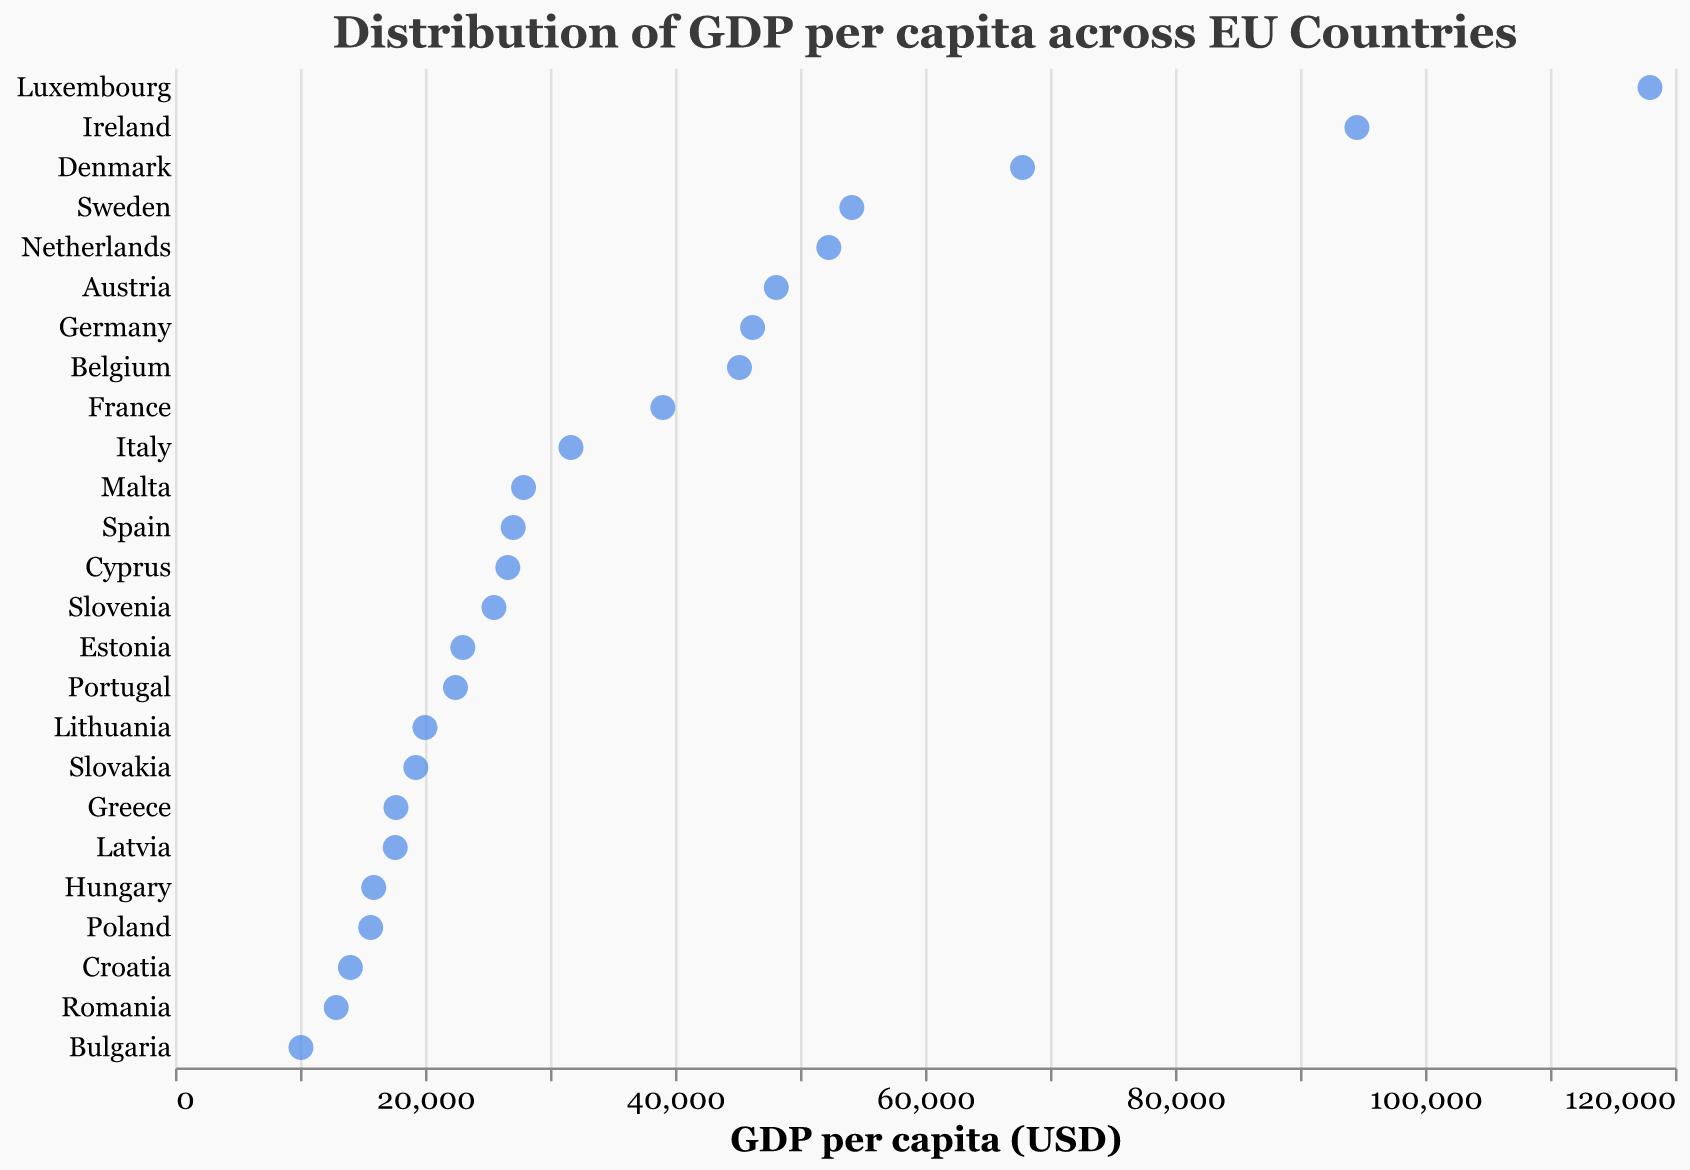Which country has the highest GDP per capita? The plot shows GDP per capita on the x-axis and countries on the y-axis. The point farthest to the right represents the highest GDP per capita. Luxembourg is the country farthest to the right.
Answer: Luxembourg Which country has the lowest GDP per capita? To find the country with the lowest GDP per capita, look for the point closest to the left on the x-axis. Bulgaria is the country closest to the left.
Answer: Bulgaria How many countries have a GDP per capita over $50,000? Identify and count the points to the right of the $50,000 mark on the x-axis. The countries are Luxembourg, Ireland, Denmark, Sweden, and the Netherlands.
Answer: 5 What is the approximate GDP per capita difference between Germany and France? Locate the points for Germany and France on the x-axis and subtract their values: 46208 (Germany) - 39030 (France) = 7178.
Answer: 7178 Which country has a higher GDP per capita, Italy or Spain? Compare the x-axis positions of the points for Italy and Spain. Italy (31676) has a higher GDP per capita than Spain (27057).
Answer: Italy What is the median GDP per capita among the countries listed? To find the median GDP per capita, line up all the values in ascending order and identify the middle one. The ordered list gives the median value around the mid-point, which is around Portugal.
Answer: Portugal (22439) How does the GDP per capita of Malta compare to Cyprus? Locate the points for Malta and Cyprus on the x-axis. Malta (27885) has a slightly higher GDP per capita than Cyprus (26624).
Answer: Malta Are there any countries with a GDP per capita between $30,000 and $40,000? Look for points on the x-axis between $30,000 and $40,000. Italy (31676) and France (39030) fall into this range.
Answer: Yes What is the range of GDP per capita values in the European Union countries? The range is calculated by subtracting the smallest value from the largest value. For this dataset, the range is 118001 (Luxembourg) - 10079 (Bulgaria) = 107922.
Answer: 107922 Is there a noticeable concentration of countries within a particular GDP per capita range? Visually inspect the plot to identify where points are clustered. There is a noticeable concentration of countries with GDP per capita between $10,000 and $30,000.
Answer: Yes 